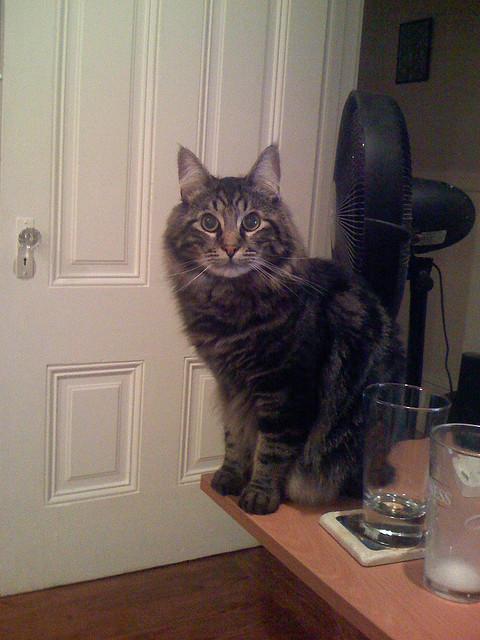How many glasses are on the table?
Give a very brief answer. 2. How many cups can be seen?
Give a very brief answer. 2. How many people are on the elephant on the right?
Give a very brief answer. 0. 